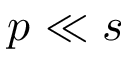<formula> <loc_0><loc_0><loc_500><loc_500>p \ll s</formula> 